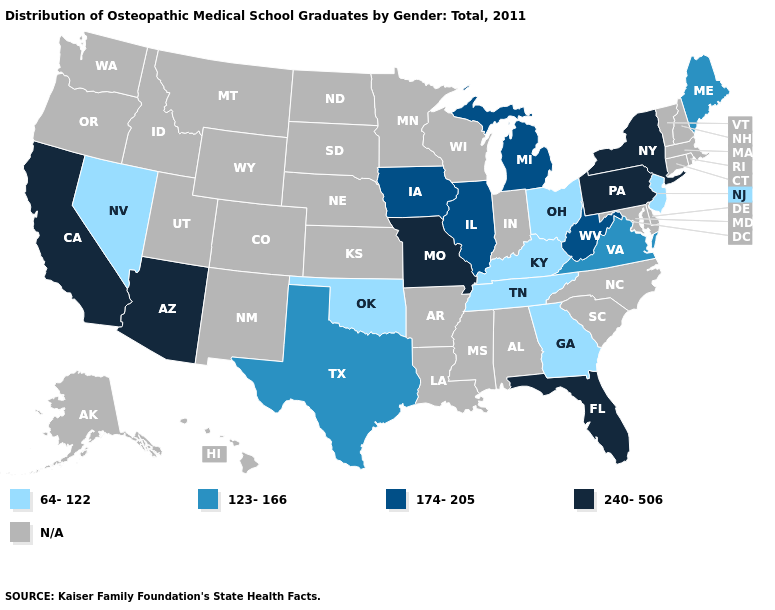How many symbols are there in the legend?
Be succinct. 5. Name the states that have a value in the range 240-506?
Concise answer only. Arizona, California, Florida, Missouri, New York, Pennsylvania. Among the states that border Maryland , does West Virginia have the lowest value?
Give a very brief answer. No. Among the states that border New Mexico , which have the lowest value?
Keep it brief. Oklahoma. Name the states that have a value in the range N/A?
Concise answer only. Alabama, Alaska, Arkansas, Colorado, Connecticut, Delaware, Hawaii, Idaho, Indiana, Kansas, Louisiana, Maryland, Massachusetts, Minnesota, Mississippi, Montana, Nebraska, New Hampshire, New Mexico, North Carolina, North Dakota, Oregon, Rhode Island, South Carolina, South Dakota, Utah, Vermont, Washington, Wisconsin, Wyoming. What is the value of Connecticut?
Short answer required. N/A. What is the value of Vermont?
Answer briefly. N/A. What is the value of Delaware?
Concise answer only. N/A. Does Pennsylvania have the highest value in the Northeast?
Keep it brief. Yes. Does New Jersey have the highest value in the Northeast?
Give a very brief answer. No. Name the states that have a value in the range 240-506?
Write a very short answer. Arizona, California, Florida, Missouri, New York, Pennsylvania. Does the map have missing data?
Be succinct. Yes. 